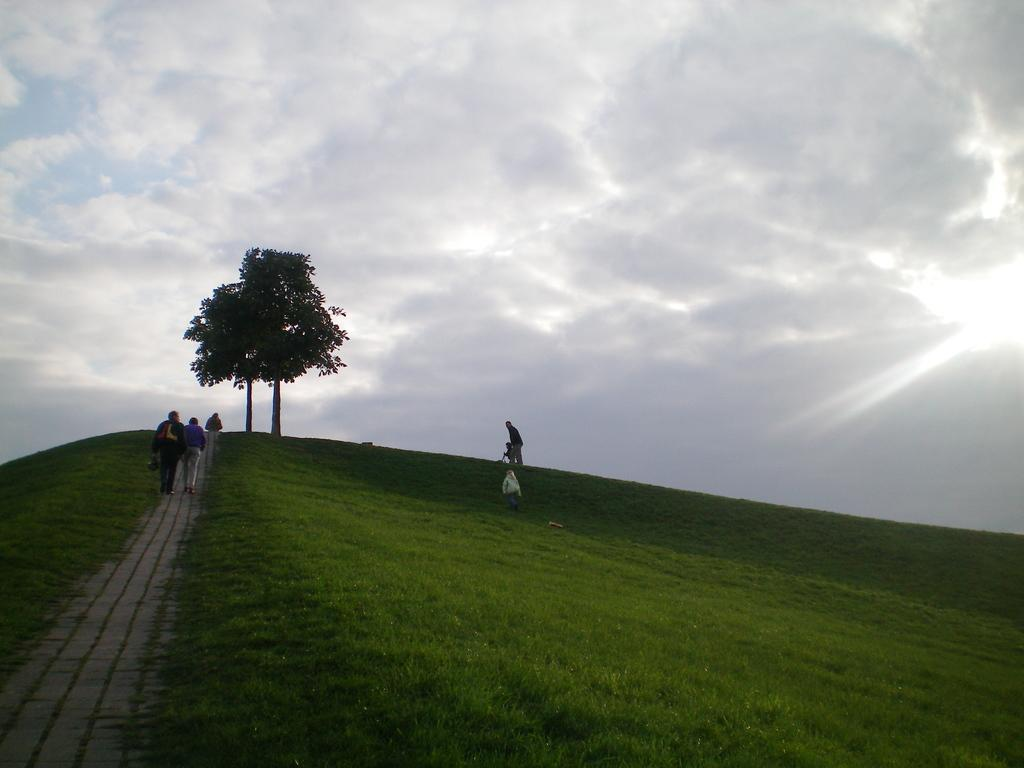What are the people in the image doing? The people in the image are walking. What might the people be carrying with them? Some people are holding bags. What type of vegetation can be seen in the image? There are trees in the image. What is the color of the grass in the image? The grass in the image is green. How would you describe the sky in the image? The sky is a combination of white and blue colors. Can you see any clams in the image? There are no clams present in the image. What type of pen is being used by the people in the image? There is no pen visible in the image; the people are walking and holding bags. 